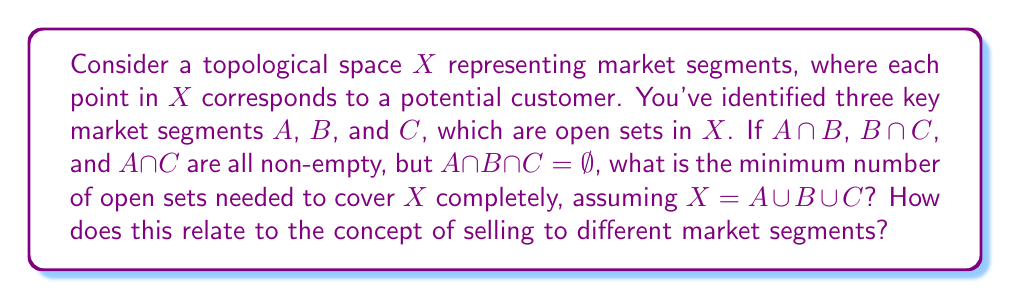Can you solve this math problem? Let's approach this step-by-step:

1) First, we need to understand what the given information tells us about the topological space $X$:
   - $X$ is composed of three open sets: $A$, $B$, and $C$
   - These sets have pairwise intersections ($A \cap B$, $B \cap C$, $A \cap C$ are non-empty)
   - The intersection of all three sets is empty ($A \cap B \cap C = \emptyset$)
   - $X = A \cup B \cup C$

2) Visualizing this, we can think of $X$ as a Venn diagram with three overlapping circles, but with no point where all three circles intersect.

3) To cover $X$ completely, we need to consider all distinct regions:
   - The part of $A$ not in $B$ or $C$
   - The part of $B$ not in $A$ or $C$
   - The part of $C$ not in $A$ or $B$
   - $A \cap B$ (not in $C$)
   - $B \cap C$ (not in $A$)
   - $A \cap C$ (not in $B$)

4) These six regions are mutually disjoint and their union is $X$.

5) Each of these regions is open in $X$ because they are intersections and differences of open sets, which are open in a topological space.

6) Therefore, the minimum number of open sets needed to cover $X$ is 6.

Relating this to selling to different market segments:

- Each open set represents a distinct group of customers with unique characteristics.
- The overlapping regions ($A \cap B$, $B \cap C$, $A \cap C$) represent customers who share characteristics of multiple segments.
- The fact that $A \cap B \cap C = \emptpty$ suggests that there are no customers who belong to all three segments simultaneously.
- As an assertive salesperson, you would need to develop at least 6 different marketing strategies to effectively target all potential customers, ensuring that your product "sells itself" to each unique group.
Answer: The minimum number of open sets needed to cover $X$ completely is 6. 